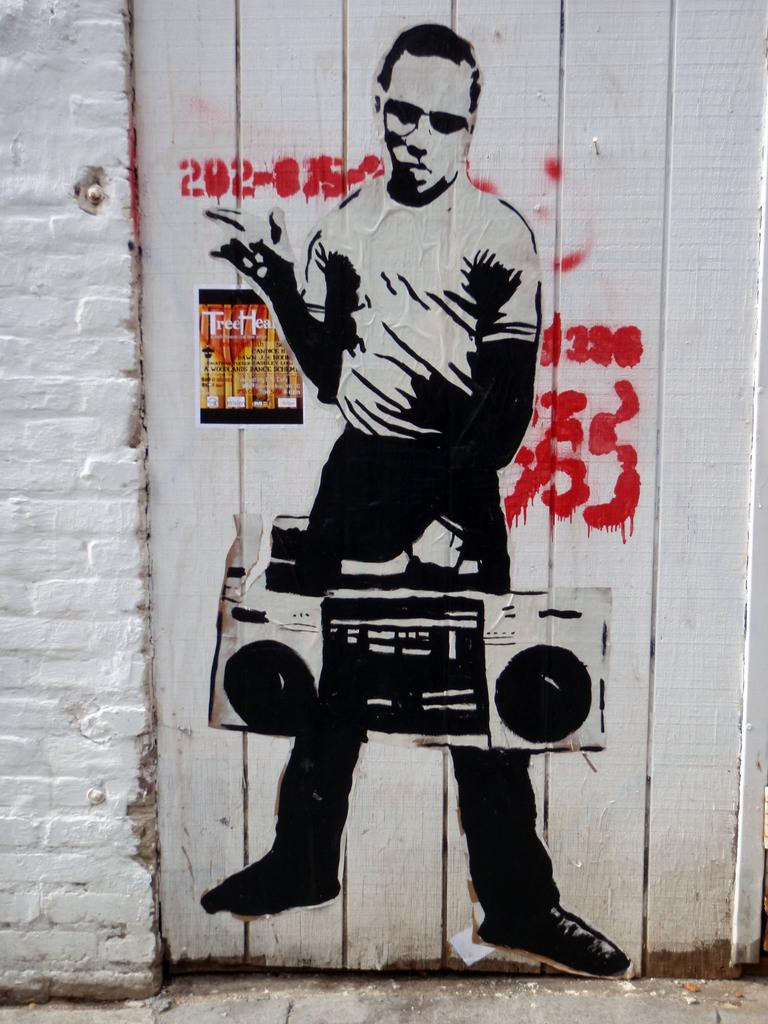What is present on the wall in the image? There is a painting on the wall in the image. What is the subject of the painting? The painting depicts a man. What object is the man holding in the painting? The man in the painting is holding a tape recorder. How many oranges are on the wall in the image? There are no oranges present on the wall in the image. What is the profit of the painting in the image? The image does not provide information about the profit of the painting. 